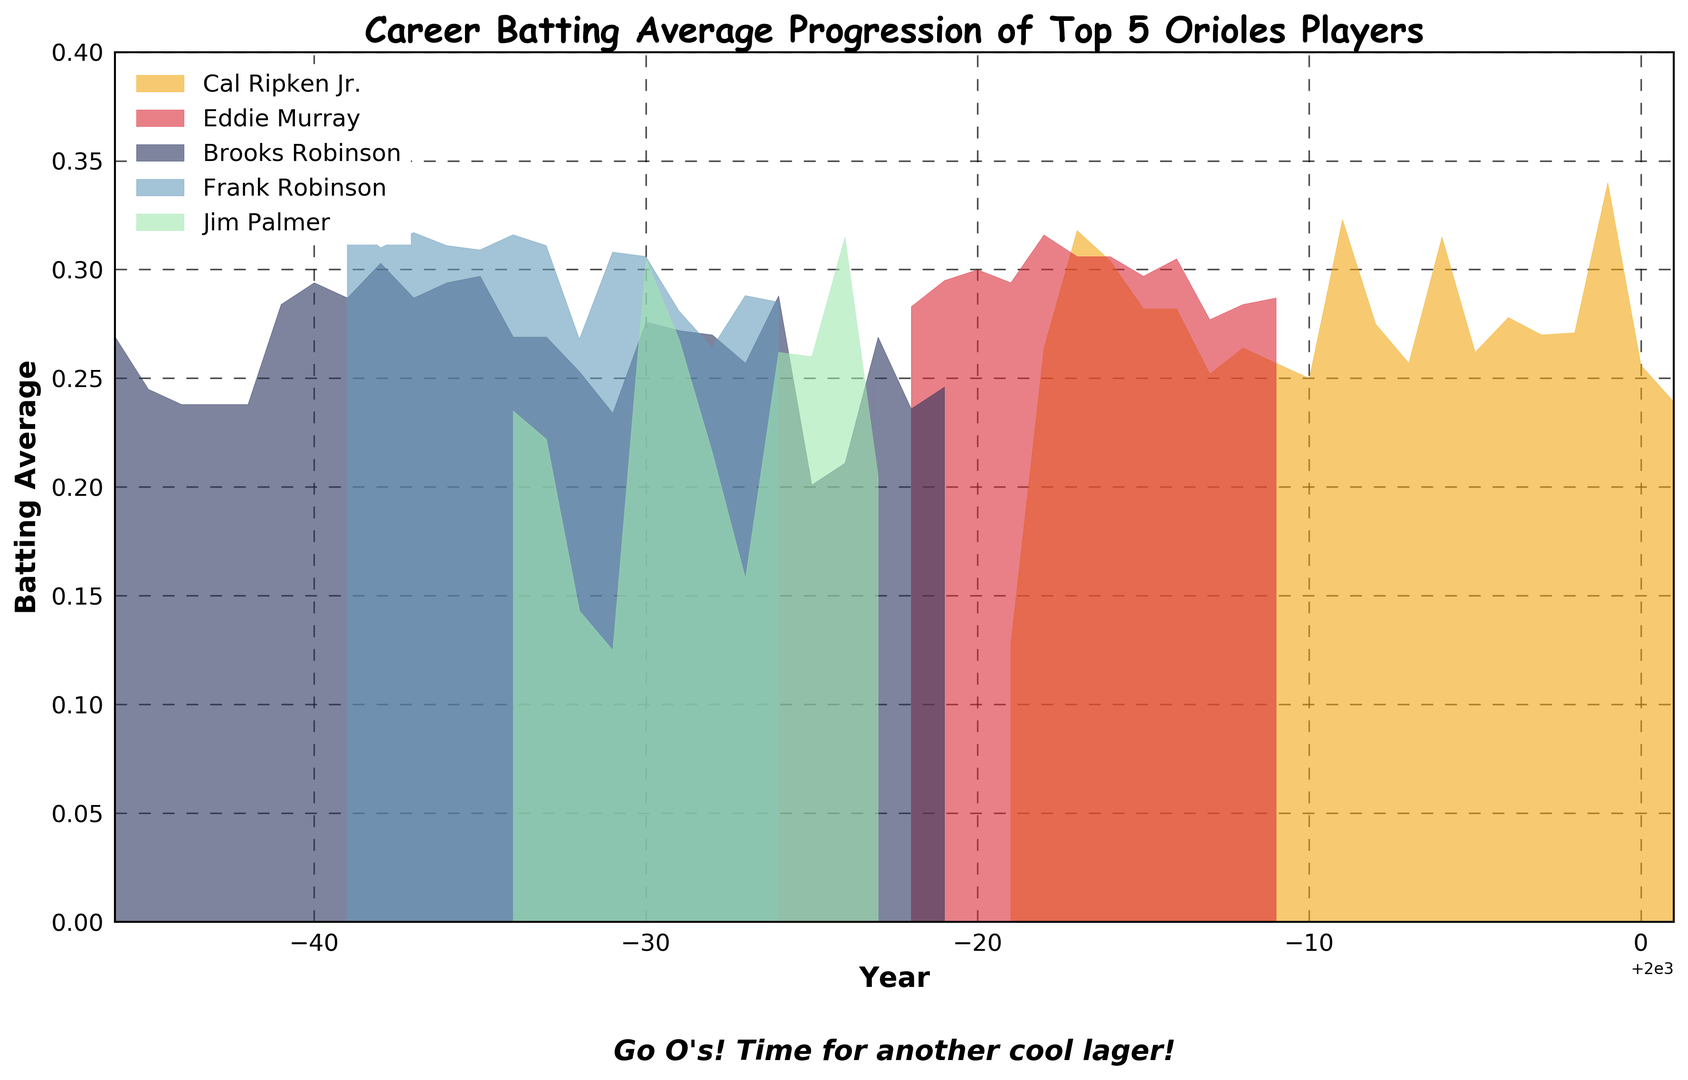Which player had the highest batting average in 1991? Look at the year 1991 and observe the height of the corresponding areas for each player. Cal Ripken Jr.'s area is present and no other players have data for 1991 in the figure.
Answer: Cal Ripken Jr Between 1954 and 1956, whose batting average showed a consistent decrease? Examine the height of the colored areas for each year between 1954 and 1956. Brooks Robinson's area decreases consistently over these years.
Answer: Brooks Robinson In which year did Frank Robinson achieve his highest batting average? Look at Frank Robinson's area chart, represented in a distinct color. Identify the peak height within his section of the chart. He peaked in 1956 and again in 1961, but the figures suggest his highest overall was 1961.
Answer: 1961 How did Eddie Murray's batting average in 1981 compare to his batting average in 1980? Check the height of Eddie's area for 1980 and 1981. Between these two years, his average stays approximately the same, suggesting a slight decrease from approximately 0.300 to 0.294.
Answer: Slight Decrease What was the trend in Cal Ripken Jr.'s batting average from 1992 to 1994? Observe the height of Cal Ripken Jr.’s area for the years 1992 through 1994. Heights go from 0.275 in 1992 to 0.257 in 1993 to 0.315 in 1994, so there is an overall decline followed by a rise.
Answer: Decline then Rise Which two players did not have any data points after 1977? Look for the last year data is available for each player. Brooks Robinson and Frank Robinson have no data points after 1977.
Answer: Brooks Robinson, Frank Robinson Across the entire chart, which player appears to have the most consistent batting average? Review the areas for each player. Eddie Murray's area shows less fluctuation compared to the other players, indicating consistency.
Answer: Eddie Murray Which player had a significant dip in batting average in 1968? Identify the year 1968 and observe which player's area significantly declines. Both Brooks Robinson and Frank Robinson show declines, but Brooks Robinson’s dip is more noticeable.
Answer: Brooks Robinson How many players had a batting average above 0.3 at any point during their career? Check the maximum heights of each player's area. Cal Ripken Jr., Eddie Murray, Brooks Robinson, and Frank Robinson all had batting averages exceeding 0.3 at some point.
Answer: Four Comparing Jim Palmer's batting average in 1970 and 1975, what can you say about his performance? Find Jim Palmer’s area for 1970 and 1975. In 1970 it is higher, around 0.305, compared to around 0.260 in 1975, showing a decrease.
Answer: Decrease 